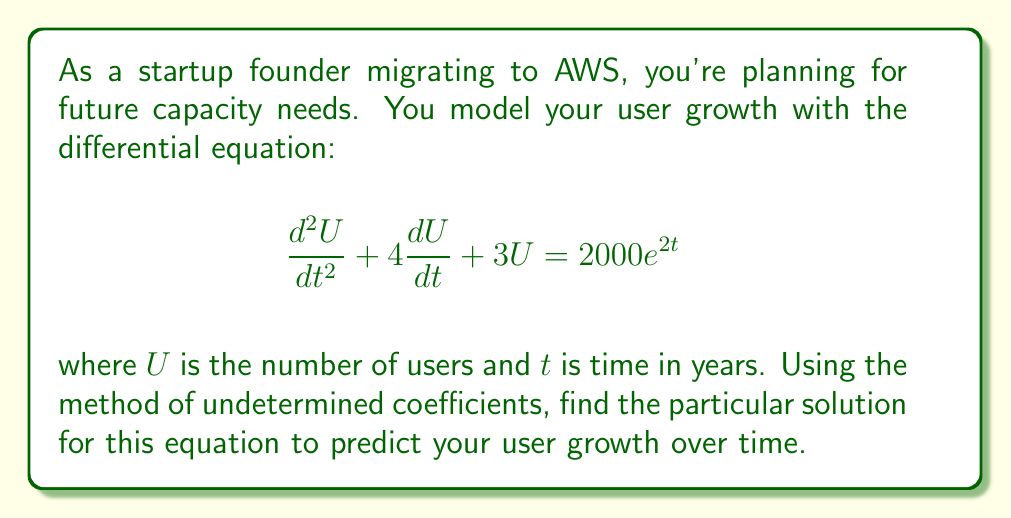Can you answer this question? To solve this non-homogeneous second-order linear differential equation using the method of undetermined coefficients, we follow these steps:

1) First, we identify the form of the particular solution. Since the right-hand side is $2000e^{2t}$, we assume a particular solution of the form:

   $U_p = Ae^{2t}$

   where $A$ is a constant to be determined.

2) We substitute this assumed solution and its derivatives into the original equation:

   $U_p = Ae^{2t}$
   $U_p' = 2Ae^{2t}$
   $U_p'' = 4Ae^{2t}$

3) Substituting these into the original equation:

   $$(4Ae^{2t}) + 4(2Ae^{2t}) + 3(Ae^{2t}) = 2000e^{2t}$$

4) Simplify:

   $$(4A + 8A + 3A)e^{2t} = 2000e^{2t}$$
   $$15Ae^{2t} = 2000e^{2t}$$

5) Equate coefficients:

   $$15A = 2000$$

6) Solve for A:

   $$A = \frac{2000}{15} = \frac{400}{3}$$

Therefore, the particular solution is:

$$U_p = \frac{400}{3}e^{2t}$$

This solution represents the forced response of the system due to the external input (in this case, the exponential growth factor). It predicts an exponential growth in users over time, which aligns with the startup's expectation of rapid scaling on AWS.
Answer: $U_p = \frac{400}{3}e^{2t}$ 